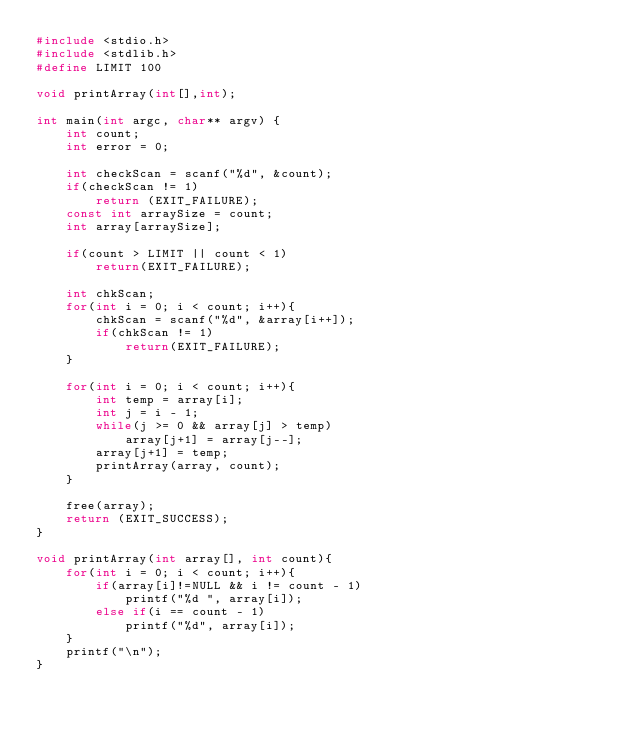<code> <loc_0><loc_0><loc_500><loc_500><_C_>#include <stdio.h>
#include <stdlib.h>
#define LIMIT 100

void printArray(int[],int);

int main(int argc, char** argv) {
    int count;
    int error = 0;
    
    int checkScan = scanf("%d", &count);
    if(checkScan != 1)
        return (EXIT_FAILURE);
    const int arraySize = count;
    int array[arraySize];
    
    if(count > LIMIT || count < 1)
        return(EXIT_FAILURE);
    
    int chkScan;
    for(int i = 0; i < count; i++){
        chkScan = scanf("%d", &array[i++]);
        if(chkScan != 1)
            return(EXIT_FAILURE);
    }
    
    for(int i = 0; i < count; i++){
        int temp = array[i];
        int j = i - 1;
        while(j >= 0 && array[j] > temp)
            array[j+1] = array[j--];
        array[j+1] = temp;
        printArray(array, count);
    }
    
    free(array);
    return (EXIT_SUCCESS);
}

void printArray(int array[], int count){
    for(int i = 0; i < count; i++){
        if(array[i]!=NULL && i != count - 1)
            printf("%d ", array[i]);
        else if(i == count - 1)
            printf("%d", array[i]);
    }
    printf("\n");
}

</code> 